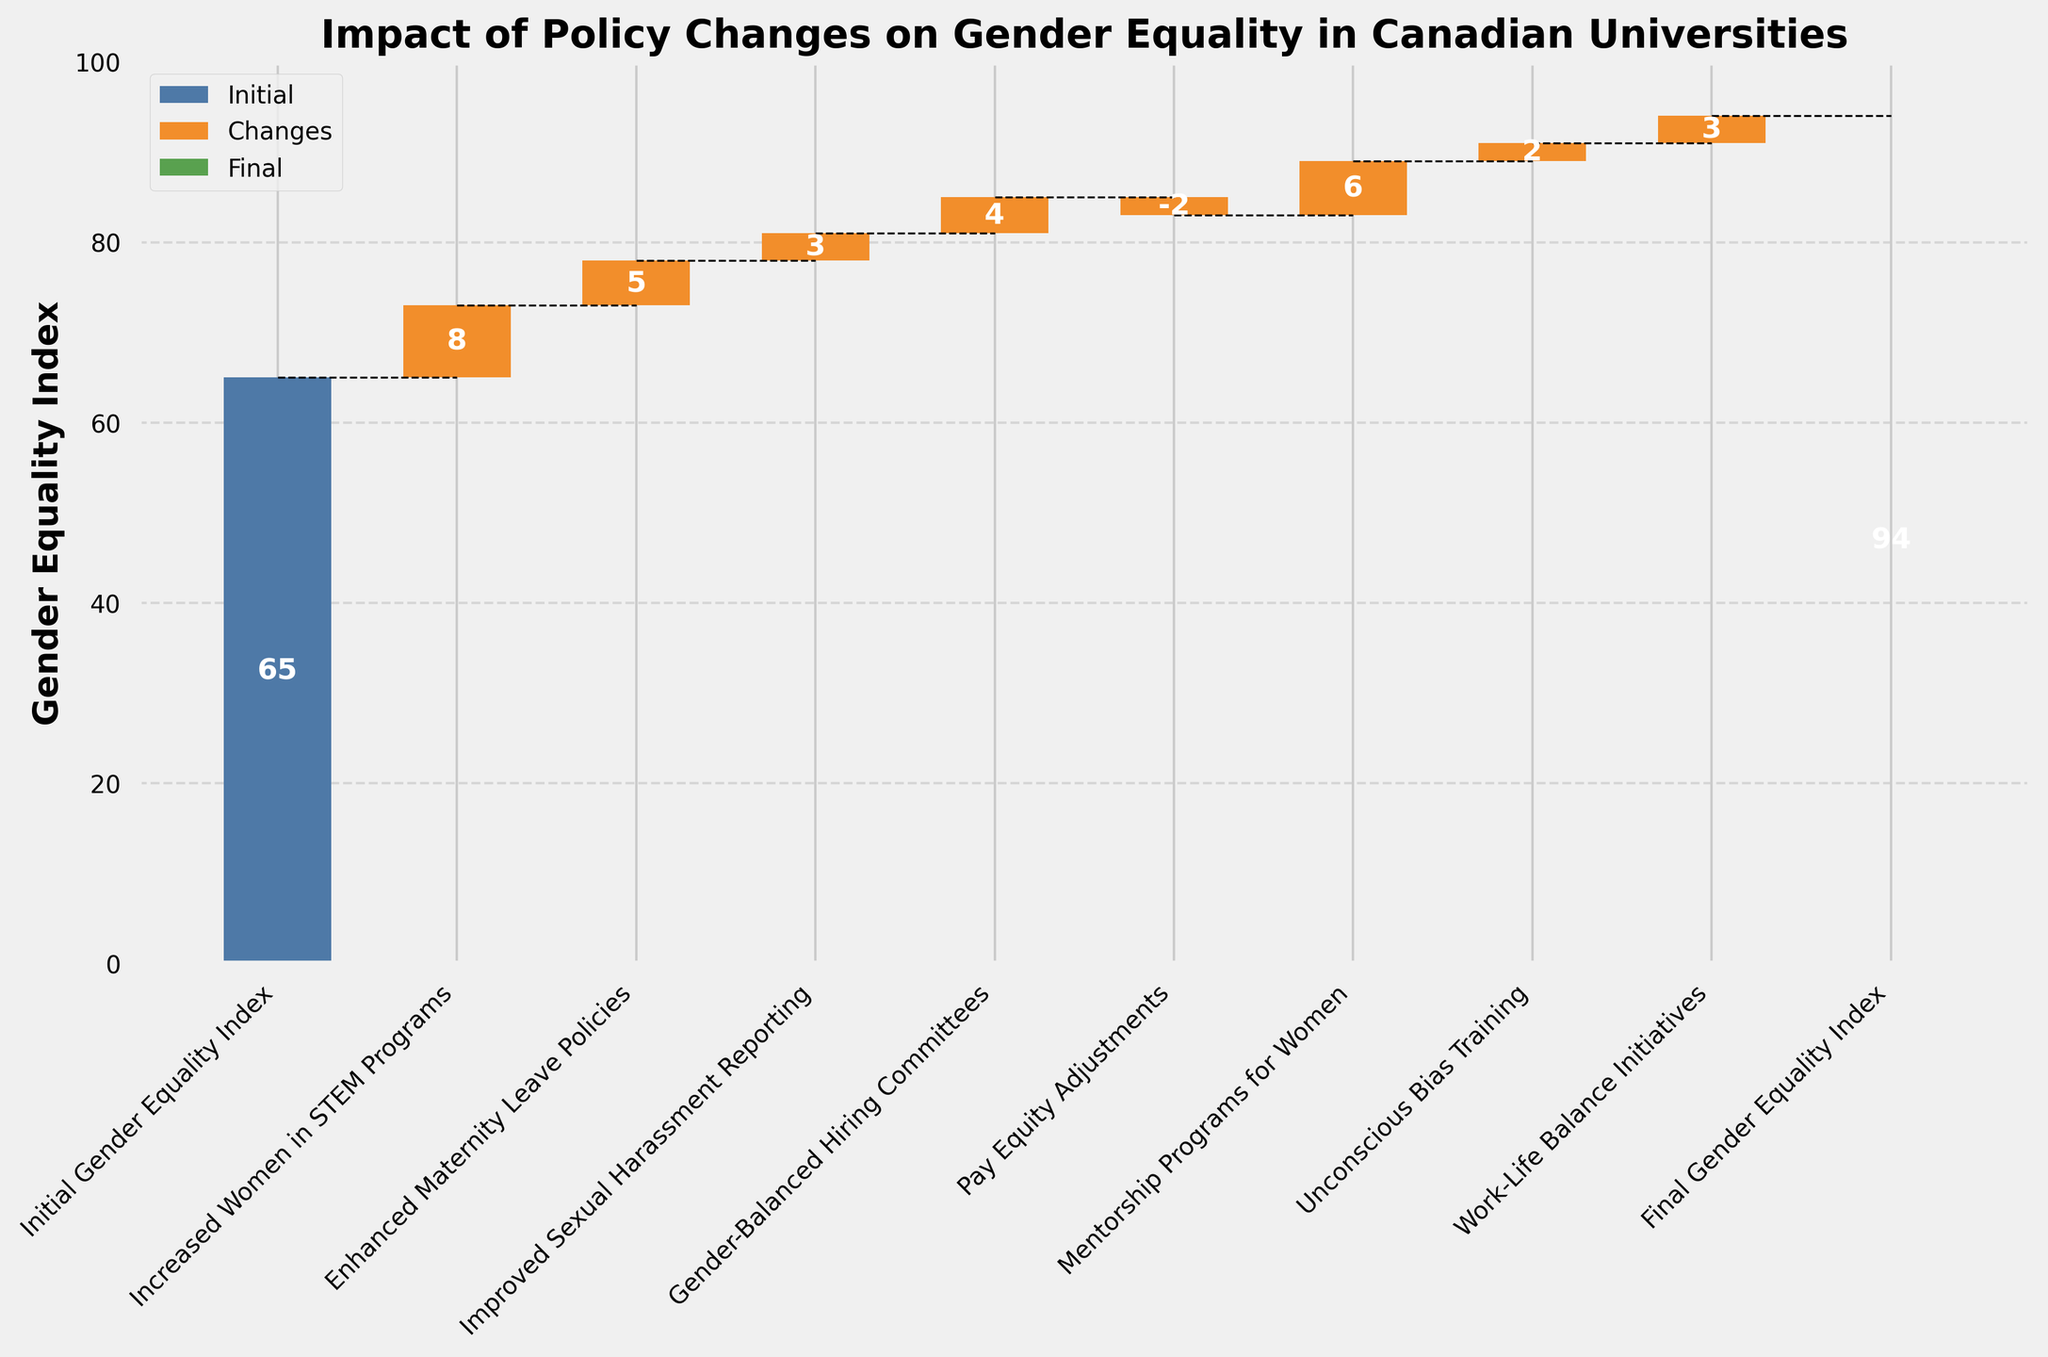What is the initial Gender Equality Index in the figure? The initial index is shown by a bar at the first position with a value label on it.
Answer: 65 What does the title of the figure indicate? The title is prominently displayed at the top of the figure and it summarizes what the chart is about.
Answer: Impact of Policy Changes on Gender Equality in Canadian Universities How much did the Gender Equality Index increase due to the 'Increased Women in STEM Programs' policy? The value for 'Increased Women in STEM Programs' is displayed inside its corresponding bar.
Answer: 8 Which policy change had a negative impact on the Gender Equality Index? The only bar with a negative value displayed inside it is for 'Pay Equity Adjustments'.
Answer: Pay Equity Adjustments What is the final Gender Equality Index? The final index is shown by a bar at the last position with a value label on it.
Answer: 94 How much total increase in the Gender Equality Index was contributed by 'Enhanced Maternity Leave Policies' and 'Improved Sexual Harassment Reporting' together? The value labels for these policies are 5 and 3, respectively. Add these two values to get the total increase.
Answer: 8 How many policy changes were considered in the figure? Count the number of bars indicating changes, excluding the initial and final values.
Answer: 7 Did the 'Mentorship Programs for Women' or 'Work-Life Balance Initiatives' contribute more to the Gender Equality Index? Compare the value labels for these two categories, which are 6 and 3, respectively.
Answer: Mentorship Programs for Women What is the overall increase in the Gender Equality Index from the initial to the final value? Subtract the initial value from the final value, i.e., 94 - 65 = 29.
Answer: 29 Which specific policy change made the least positive contribution to the Gender Equality Index? Identify the policy change with the smallest positive value displayed inside its corresponding bar.
Answer: Unconscious Bias Training 